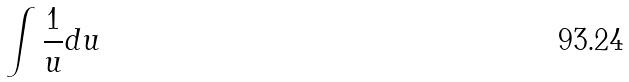<formula> <loc_0><loc_0><loc_500><loc_500>\int \frac { 1 } { u } d u</formula> 